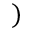Convert formula to latex. <formula><loc_0><loc_0><loc_500><loc_500>)</formula> 